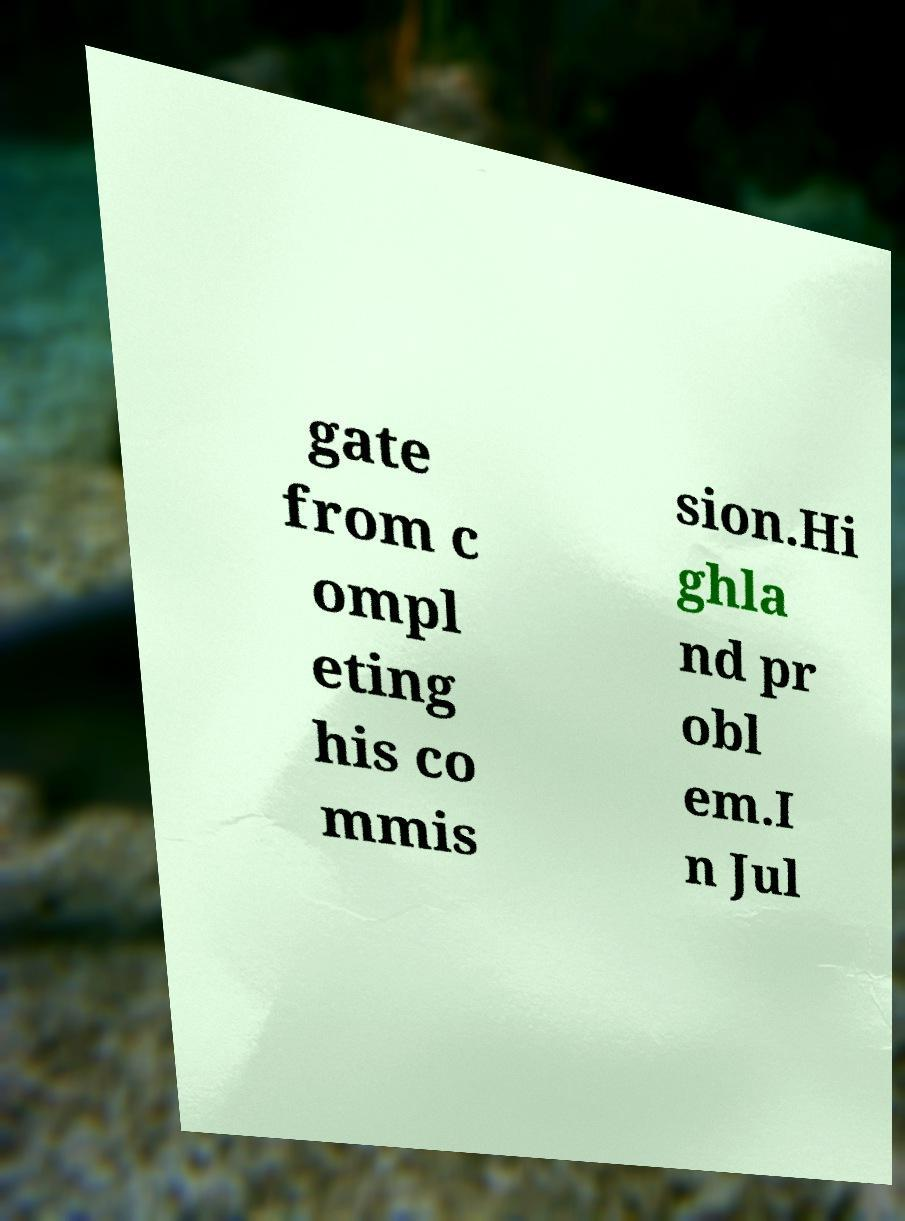There's text embedded in this image that I need extracted. Can you transcribe it verbatim? gate from c ompl eting his co mmis sion.Hi ghla nd pr obl em.I n Jul 